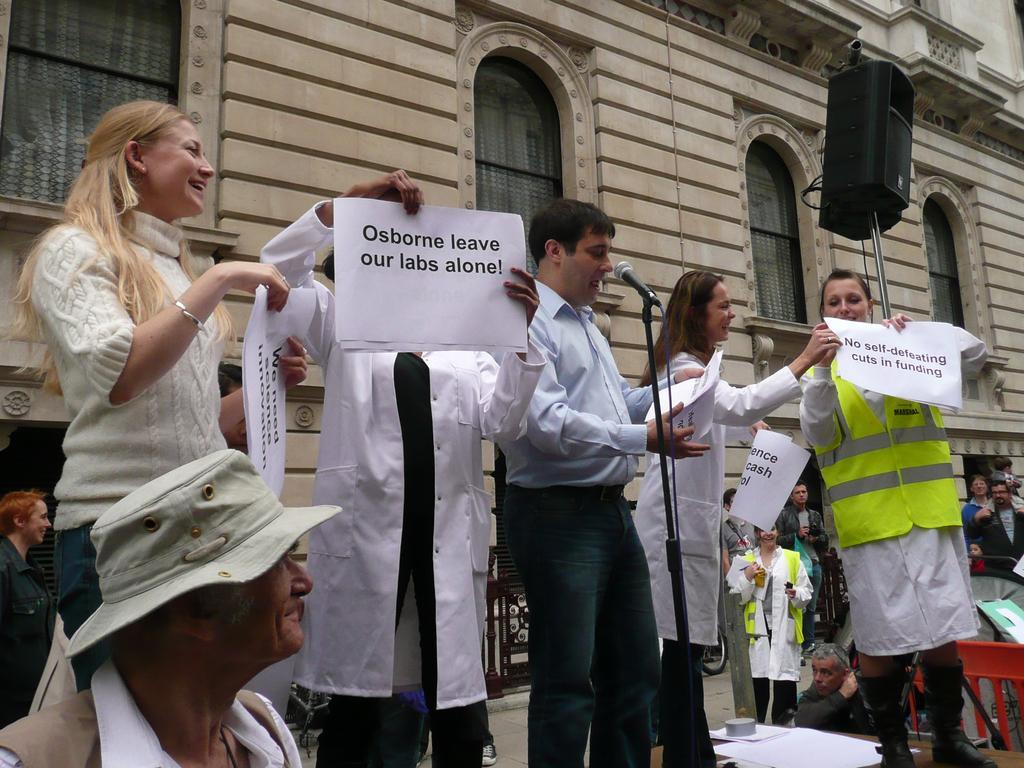In one or two sentences, can you explain what this image depicts? In this image we can see persons, microphone, papers and other objects. In the background of the image there is a building, persons and other objects. 